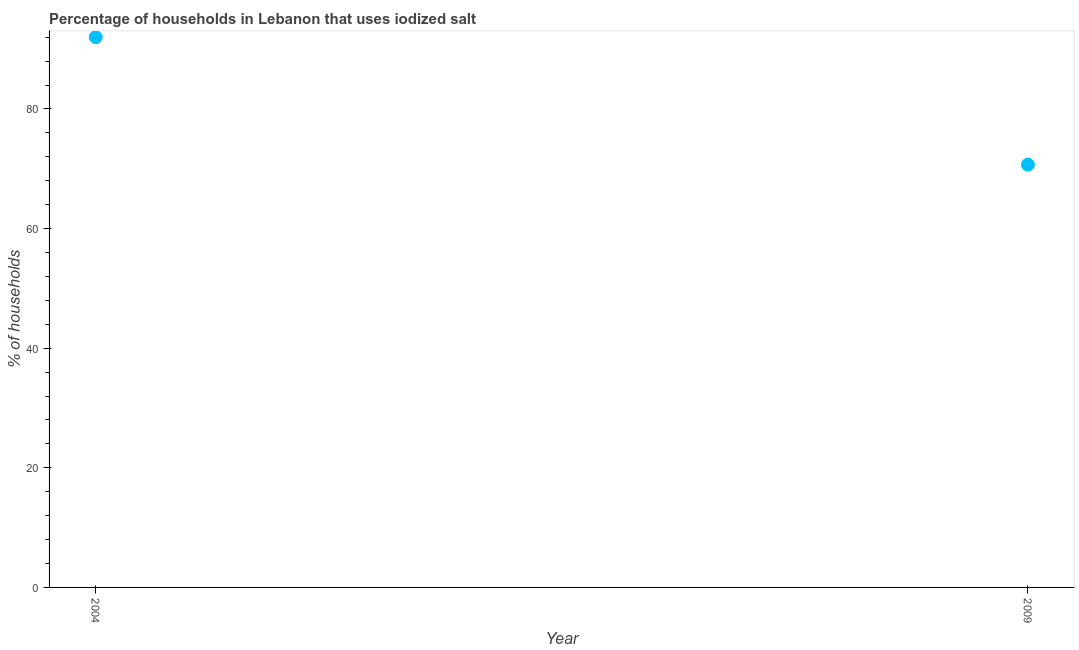What is the percentage of households where iodized salt is consumed in 2004?
Offer a terse response. 92. Across all years, what is the maximum percentage of households where iodized salt is consumed?
Your answer should be very brief. 92. Across all years, what is the minimum percentage of households where iodized salt is consumed?
Offer a terse response. 70.7. In which year was the percentage of households where iodized salt is consumed minimum?
Ensure brevity in your answer.  2009. What is the sum of the percentage of households where iodized salt is consumed?
Offer a very short reply. 162.7. What is the difference between the percentage of households where iodized salt is consumed in 2004 and 2009?
Keep it short and to the point. 21.3. What is the average percentage of households where iodized salt is consumed per year?
Provide a short and direct response. 81.35. What is the median percentage of households where iodized salt is consumed?
Your answer should be very brief. 81.35. In how many years, is the percentage of households where iodized salt is consumed greater than 84 %?
Ensure brevity in your answer.  1. Do a majority of the years between 2009 and 2004 (inclusive) have percentage of households where iodized salt is consumed greater than 64 %?
Offer a terse response. No. What is the ratio of the percentage of households where iodized salt is consumed in 2004 to that in 2009?
Ensure brevity in your answer.  1.3. In how many years, is the percentage of households where iodized salt is consumed greater than the average percentage of households where iodized salt is consumed taken over all years?
Your response must be concise. 1. Does the percentage of households where iodized salt is consumed monotonically increase over the years?
Offer a very short reply. No. What is the difference between two consecutive major ticks on the Y-axis?
Give a very brief answer. 20. Are the values on the major ticks of Y-axis written in scientific E-notation?
Provide a succinct answer. No. Does the graph contain any zero values?
Your answer should be very brief. No. What is the title of the graph?
Give a very brief answer. Percentage of households in Lebanon that uses iodized salt. What is the label or title of the X-axis?
Your answer should be very brief. Year. What is the label or title of the Y-axis?
Keep it short and to the point. % of households. What is the % of households in 2004?
Offer a terse response. 92. What is the % of households in 2009?
Offer a terse response. 70.7. What is the difference between the % of households in 2004 and 2009?
Offer a very short reply. 21.3. What is the ratio of the % of households in 2004 to that in 2009?
Give a very brief answer. 1.3. 